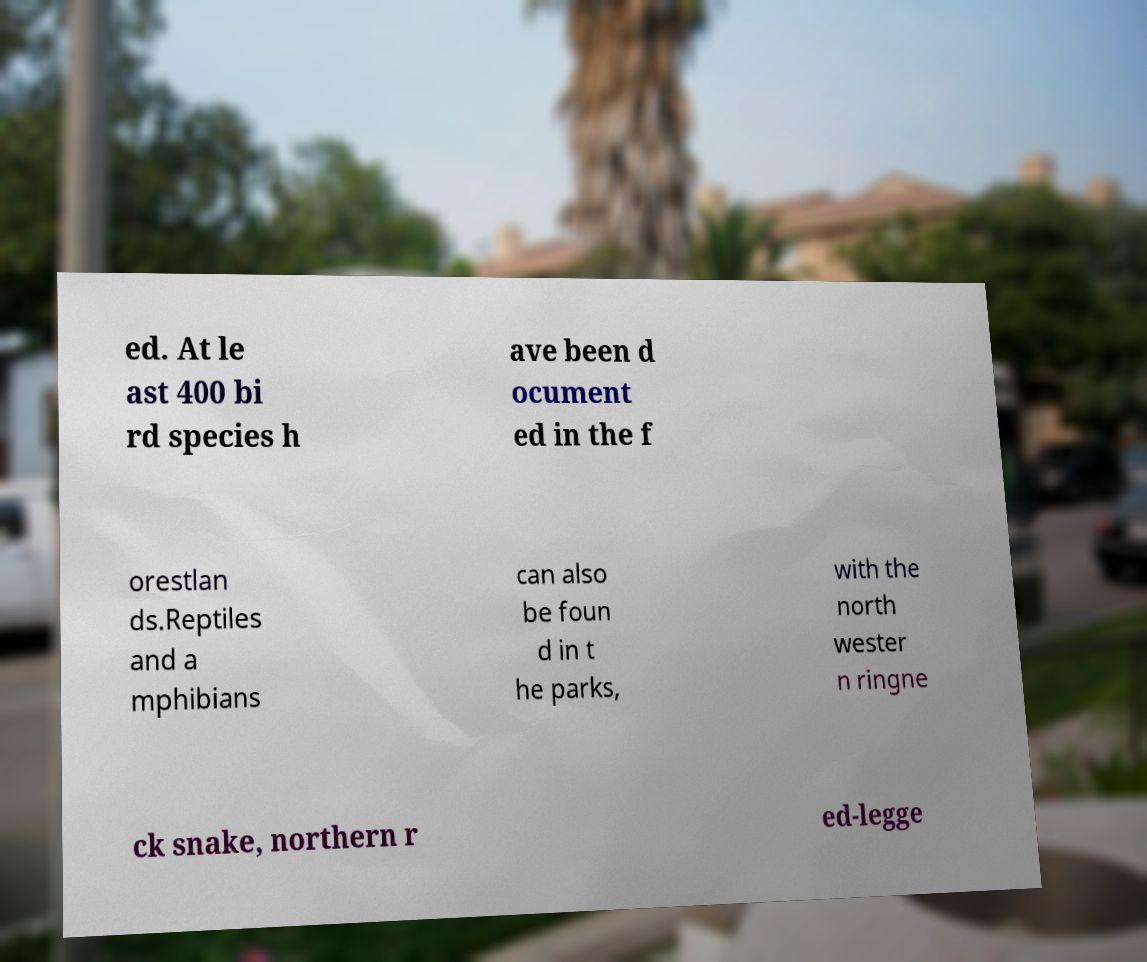Can you accurately transcribe the text from the provided image for me? ed. At le ast 400 bi rd species h ave been d ocument ed in the f orestlan ds.Reptiles and a mphibians can also be foun d in t he parks, with the north wester n ringne ck snake, northern r ed-legge 